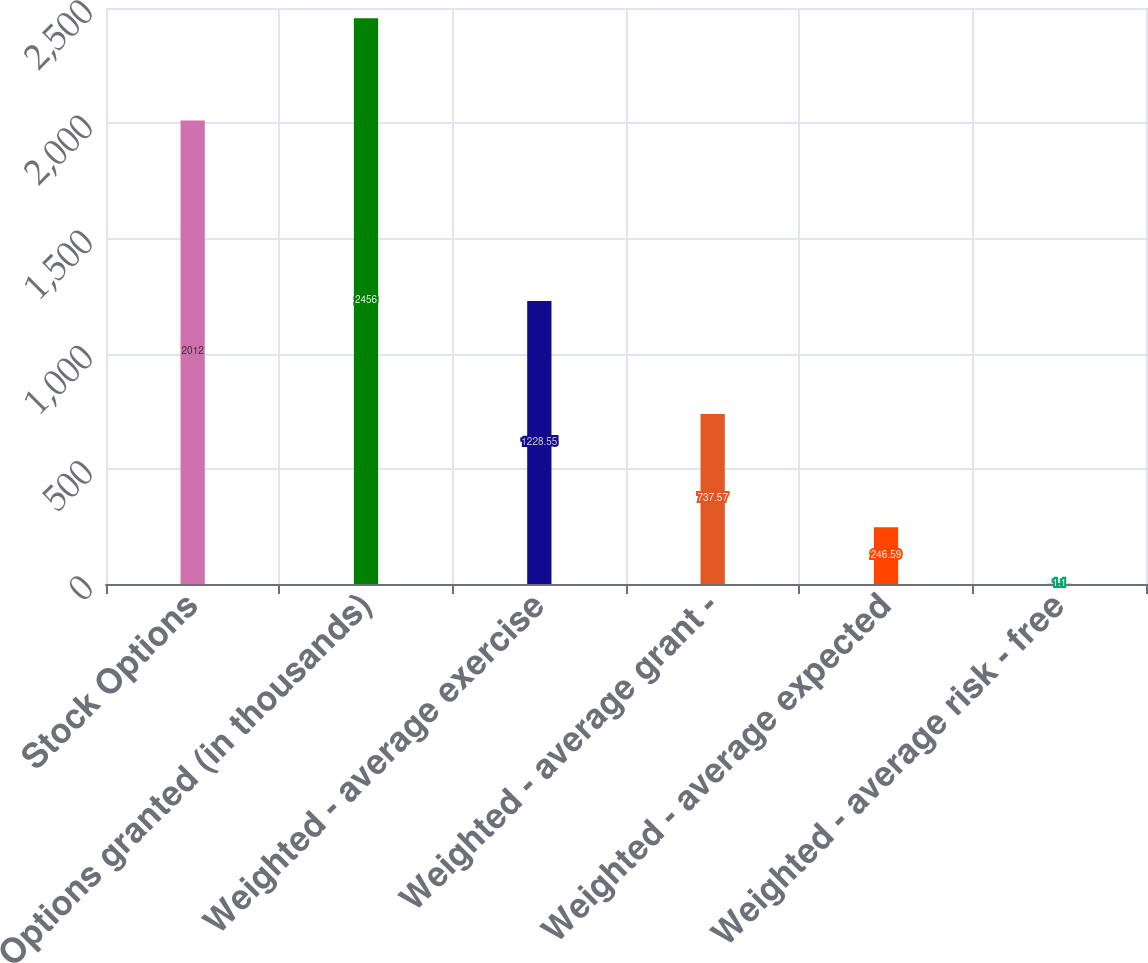Convert chart to OTSL. <chart><loc_0><loc_0><loc_500><loc_500><bar_chart><fcel>Stock Options<fcel>Options granted (in thousands)<fcel>Weighted - average exercise<fcel>Weighted - average grant -<fcel>Weighted - average expected<fcel>Weighted - average risk - free<nl><fcel>2012<fcel>2456<fcel>1228.55<fcel>737.57<fcel>246.59<fcel>1.1<nl></chart> 